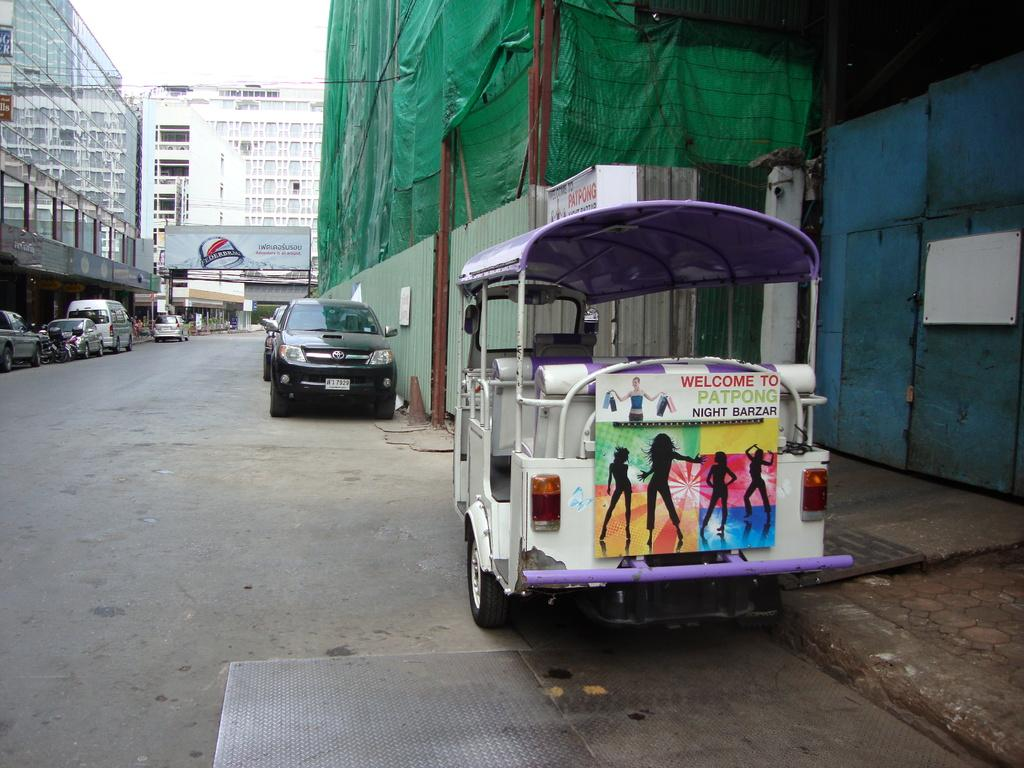What type of structures can be seen in the image? There are buildings in the image. What vehicles are parked in the image? There are cars parked in the image. What type of signage is present in the image? There is an advertisement hoarding in the image. How would you describe the weather based on the image? The sky is cloudy in the image. What mode of transportation is visible on the side of the image? There is an auto rickshaw on the side of the image. Can you see any fairies flying around the buildings in the image? There are no fairies present in the image. What type of scarf is being used by the auto rickshaw driver in the image? There is no scarf visible on the auto rickshaw driver in the image. 